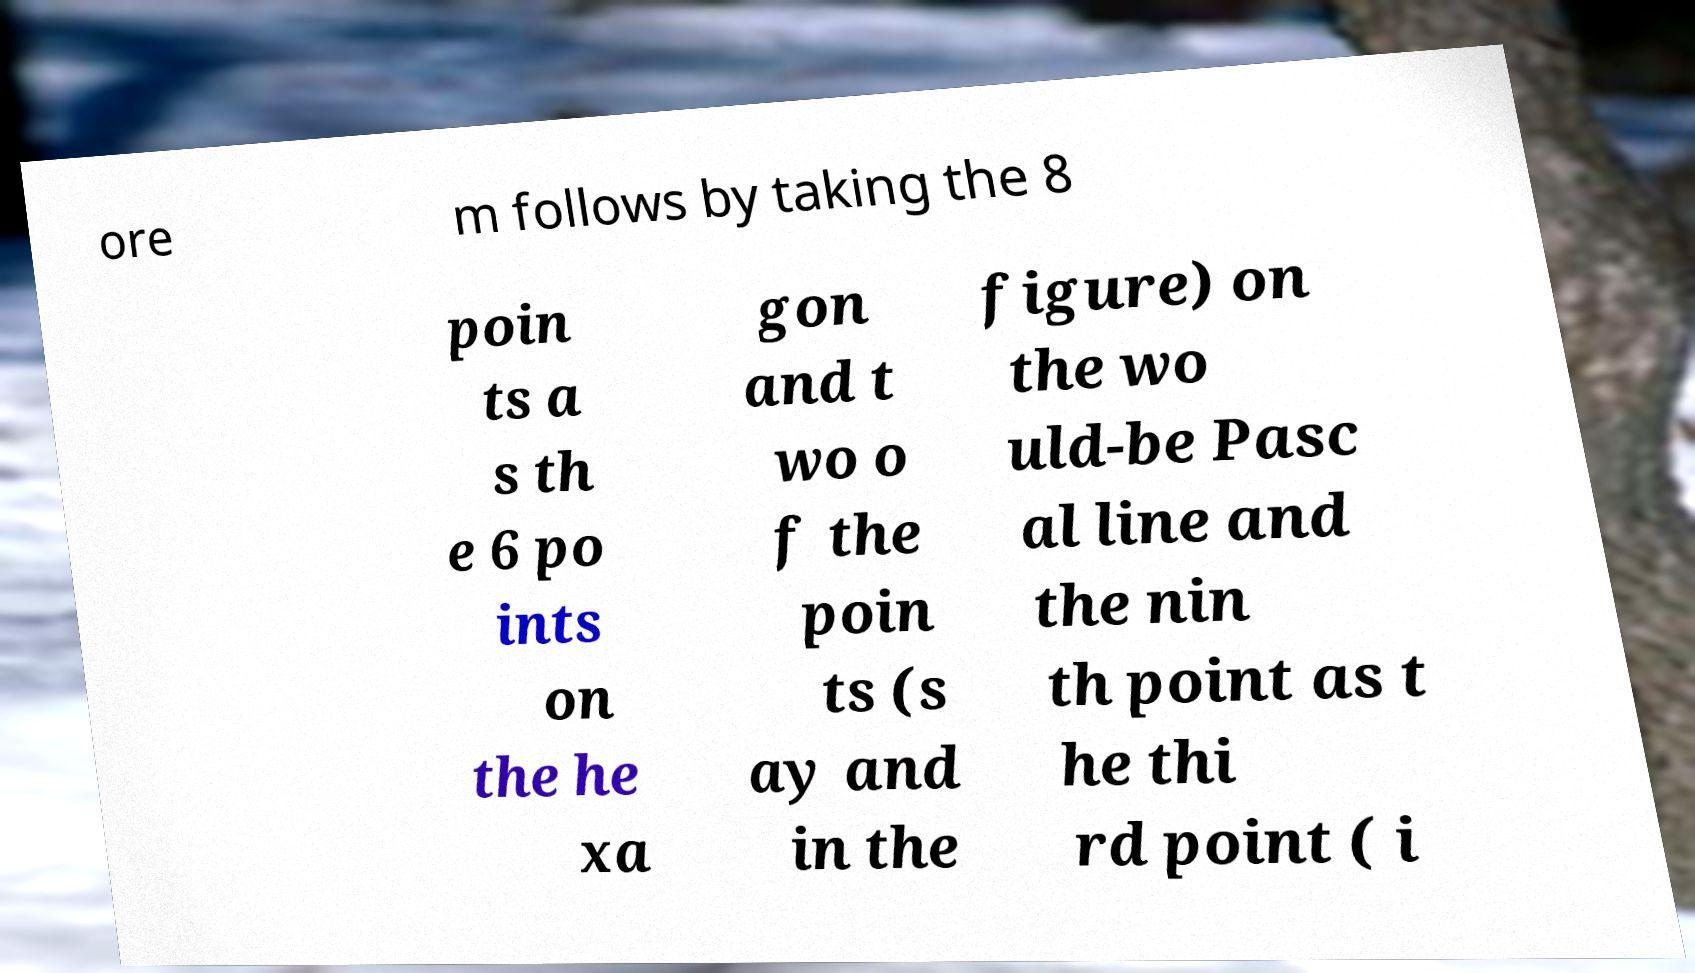Can you read and provide the text displayed in the image?This photo seems to have some interesting text. Can you extract and type it out for me? ore m follows by taking the 8 poin ts a s th e 6 po ints on the he xa gon and t wo o f the poin ts (s ay and in the figure) on the wo uld-be Pasc al line and the nin th point as t he thi rd point ( i 